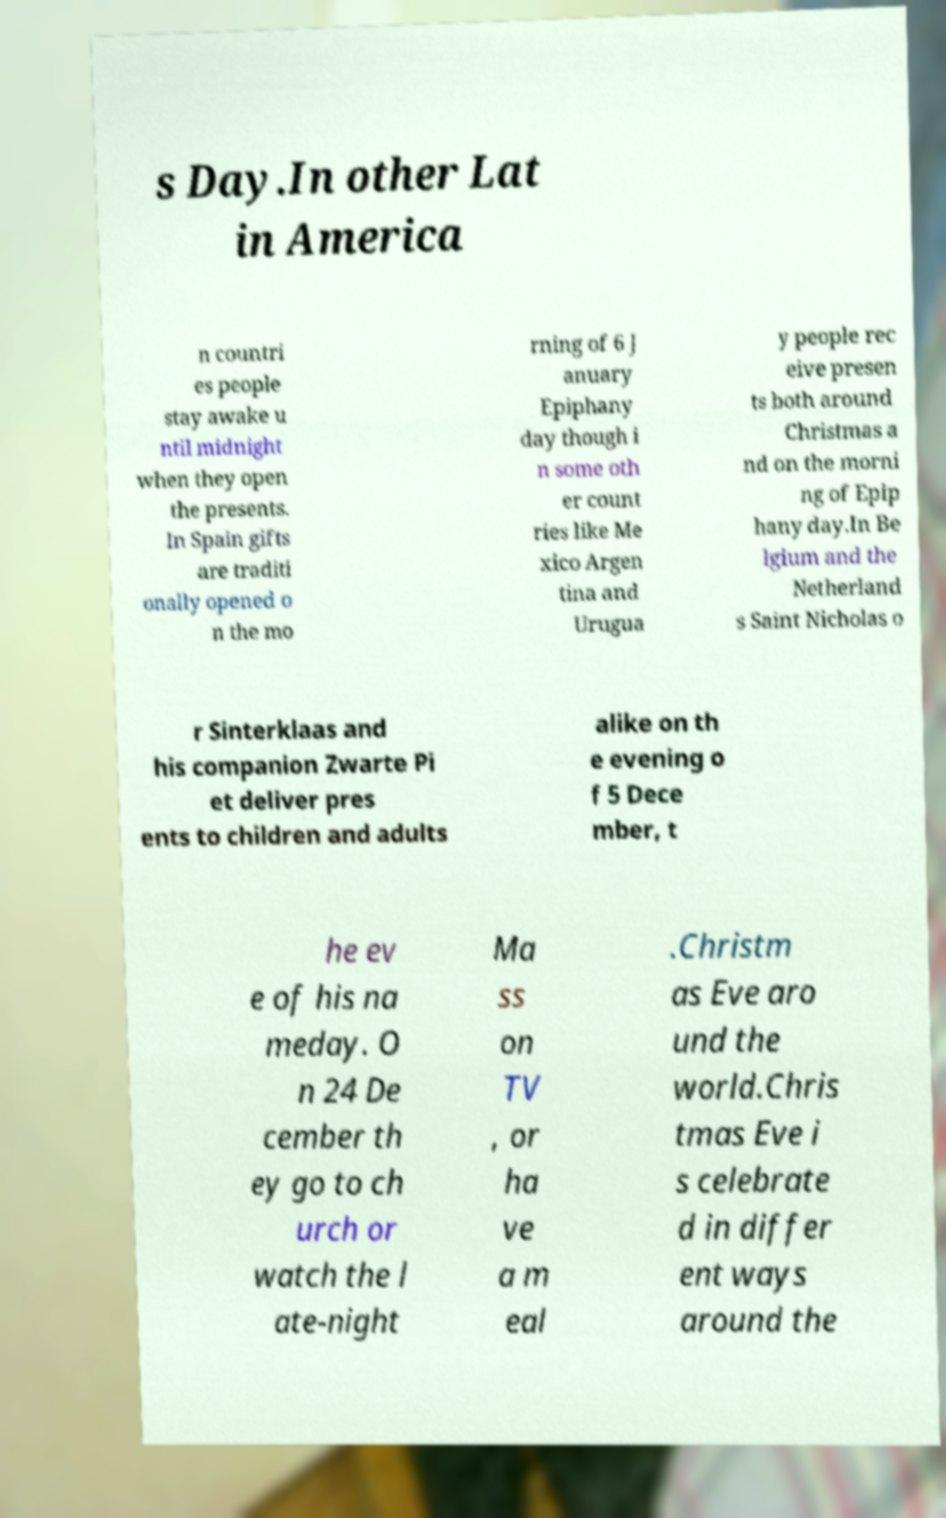Can you accurately transcribe the text from the provided image for me? s Day.In other Lat in America n countri es people stay awake u ntil midnight when they open the presents. In Spain gifts are traditi onally opened o n the mo rning of 6 J anuary Epiphany day though i n some oth er count ries like Me xico Argen tina and Urugua y people rec eive presen ts both around Christmas a nd on the morni ng of Epip hany day.In Be lgium and the Netherland s Saint Nicholas o r Sinterklaas and his companion Zwarte Pi et deliver pres ents to children and adults alike on th e evening o f 5 Dece mber, t he ev e of his na meday. O n 24 De cember th ey go to ch urch or watch the l ate-night Ma ss on TV , or ha ve a m eal .Christm as Eve aro und the world.Chris tmas Eve i s celebrate d in differ ent ways around the 